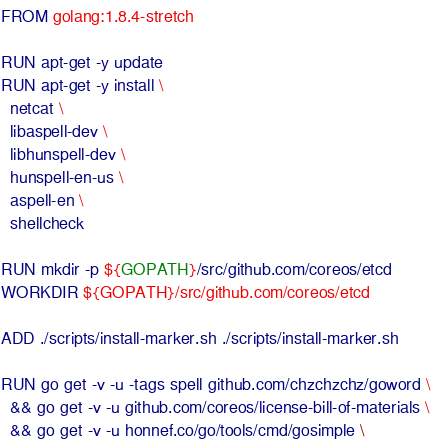Convert code to text. <code><loc_0><loc_0><loc_500><loc_500><_Dockerfile_>FROM golang:1.8.4-stretch

RUN apt-get -y update
RUN apt-get -y install \
  netcat \
  libaspell-dev \
  libhunspell-dev \
  hunspell-en-us \
  aspell-en \
  shellcheck

RUN mkdir -p ${GOPATH}/src/github.com/coreos/etcd
WORKDIR ${GOPATH}/src/github.com/coreos/etcd

ADD ./scripts/install-marker.sh ./scripts/install-marker.sh

RUN go get -v -u -tags spell github.com/chzchzchz/goword \
  && go get -v -u github.com/coreos/license-bill-of-materials \
  && go get -v -u honnef.co/go/tools/cmd/gosimple \</code> 